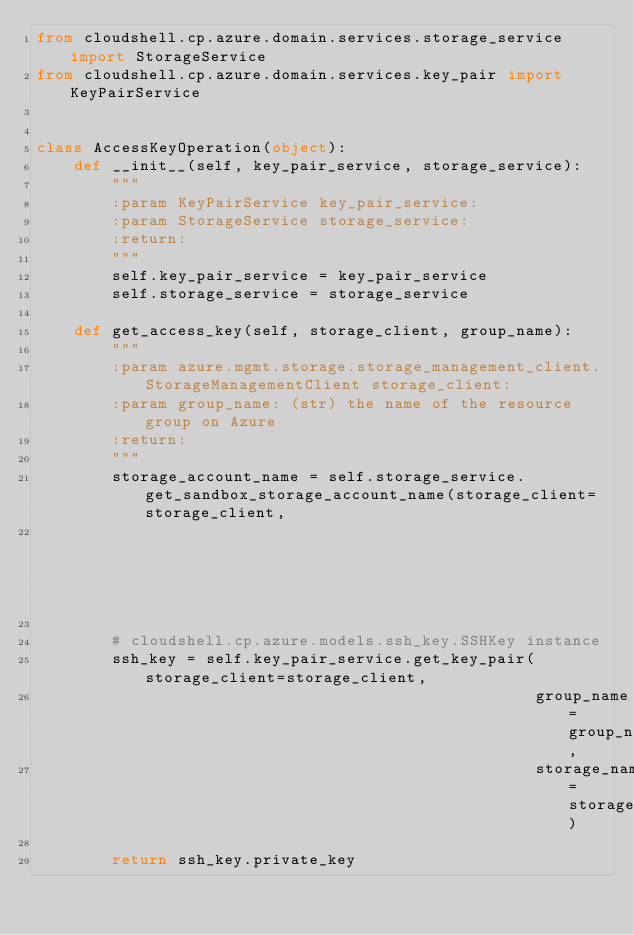<code> <loc_0><loc_0><loc_500><loc_500><_Python_>from cloudshell.cp.azure.domain.services.storage_service import StorageService
from cloudshell.cp.azure.domain.services.key_pair import KeyPairService


class AccessKeyOperation(object):
    def __init__(self, key_pair_service, storage_service):
        """
        :param KeyPairService key_pair_service:
        :param StorageService storage_service:
        :return:
        """
        self.key_pair_service = key_pair_service
        self.storage_service = storage_service

    def get_access_key(self, storage_client, group_name):
        """
        :param azure.mgmt.storage.storage_management_client.StorageManagementClient storage_client:
        :param group_name: (str) the name of the resource group on Azure
        :return:
        """
        storage_account_name = self.storage_service.get_sandbox_storage_account_name(storage_client=storage_client,
                                                                                     group_name=group_name)

        # cloudshell.cp.azure.models.ssh_key.SSHKey instance
        ssh_key = self.key_pair_service.get_key_pair(storage_client=storage_client,
                                                     group_name=group_name,
                                                     storage_name=storage_account_name)

        return ssh_key.private_key
</code> 